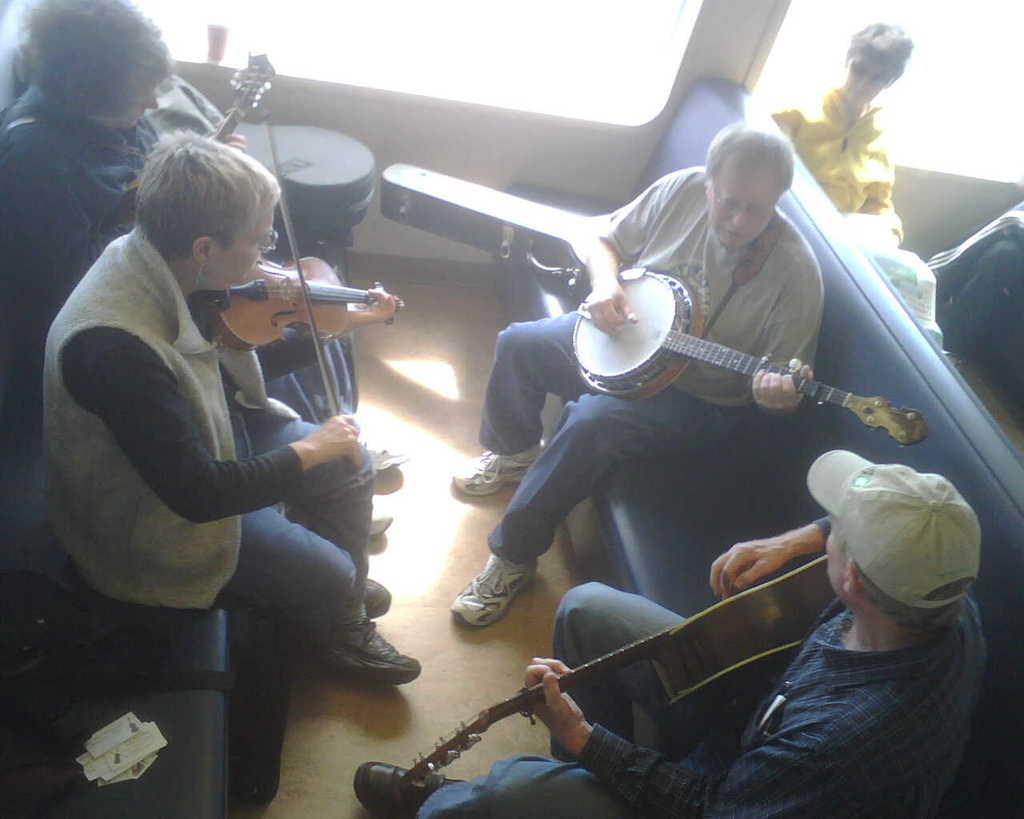What is happening in the image? There is a group of people in the image. Where are the people sitting? The people are sitting on a couch. What are the people doing while sitting on the couch? The people are playing musical instruments. What type of pies can be seen on the table in the image? There is no table or pies present in the image; it features a group of people sitting on a couch and playing musical instruments. Is there a pipe visible in the image? There is no pipe present in the image. 